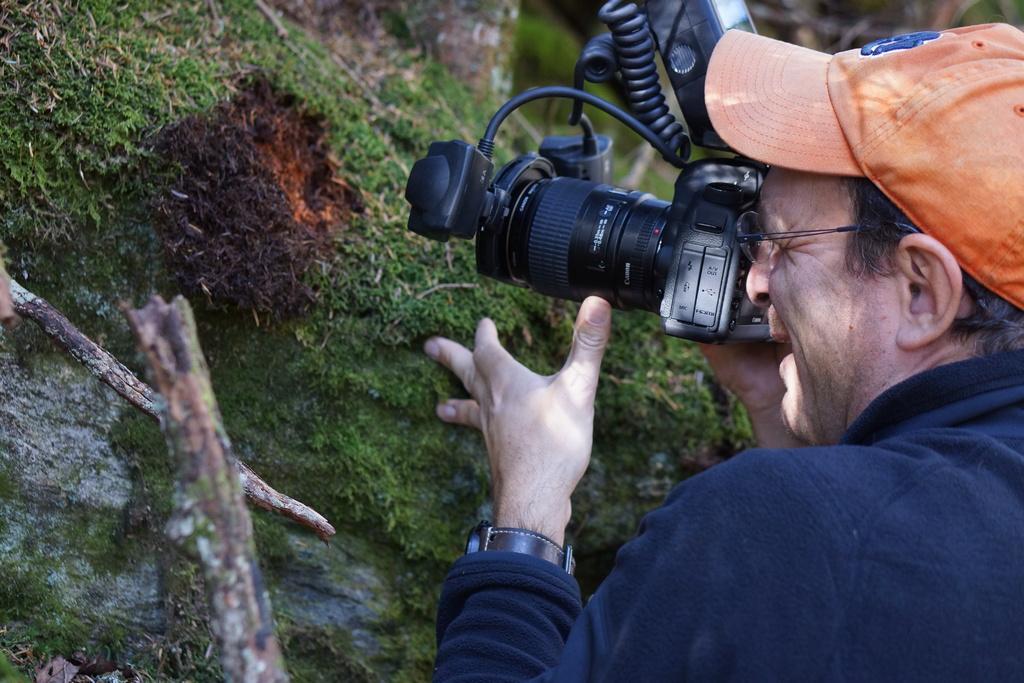Could you give a brief overview of what you see in this image? In this image i can see a person wearing a hat holding a camera. 